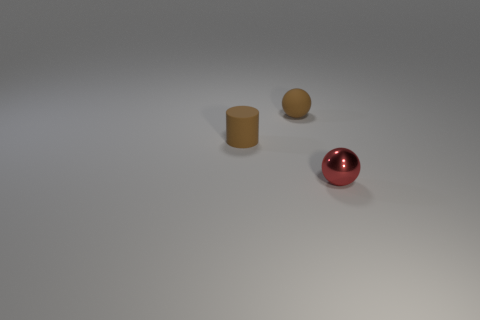Add 3 tiny red balls. How many objects exist? 6 Subtract all balls. How many objects are left? 1 Subtract all small red metallic blocks. Subtract all small brown rubber balls. How many objects are left? 2 Add 3 red metallic things. How many red metallic things are left? 4 Add 3 brown rubber objects. How many brown rubber objects exist? 5 Subtract 0 blue cylinders. How many objects are left? 3 